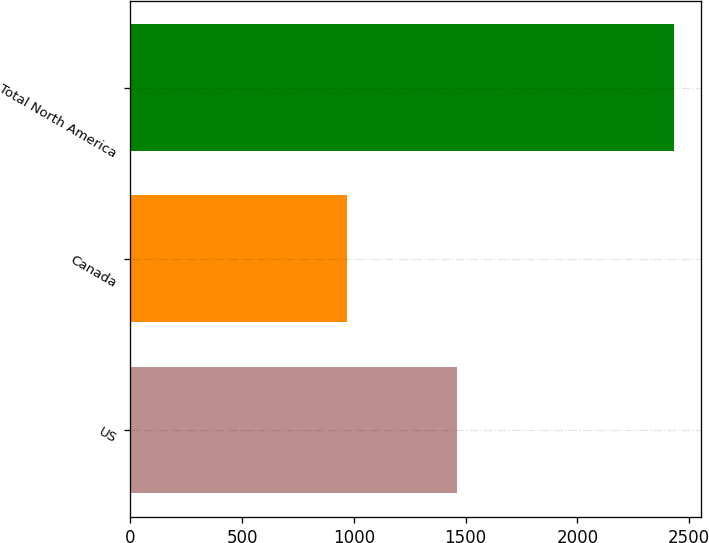Convert chart to OTSL. <chart><loc_0><loc_0><loc_500><loc_500><bar_chart><fcel>US<fcel>Canada<fcel>Total North America<nl><fcel>1463<fcel>967<fcel>2430<nl></chart> 